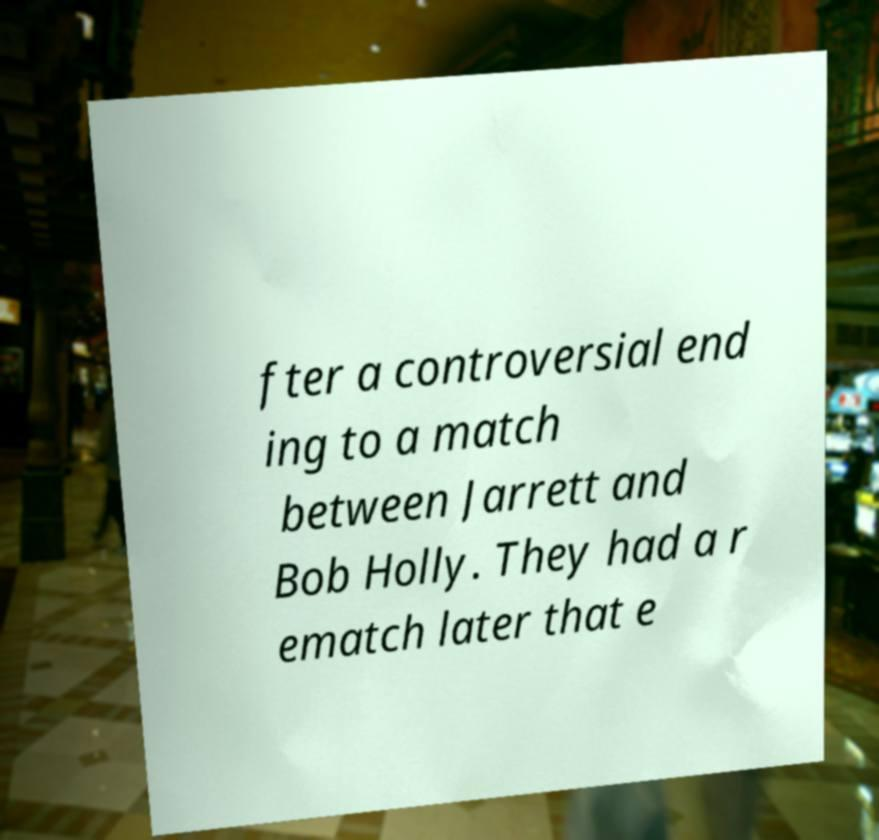Could you extract and type out the text from this image? fter a controversial end ing to a match between Jarrett and Bob Holly. They had a r ematch later that e 